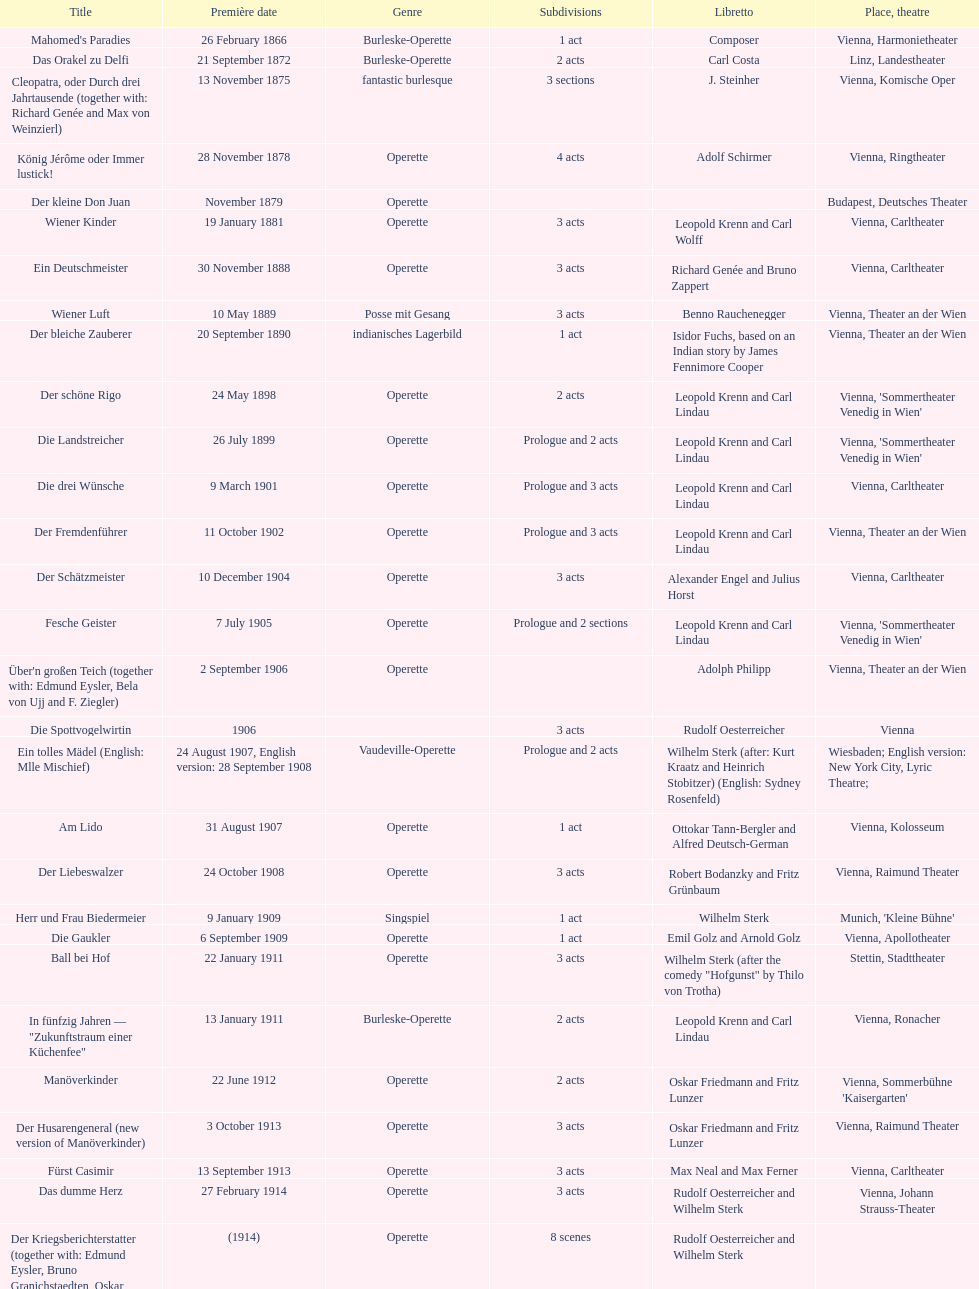How many number of 1 acts were there? 5. 